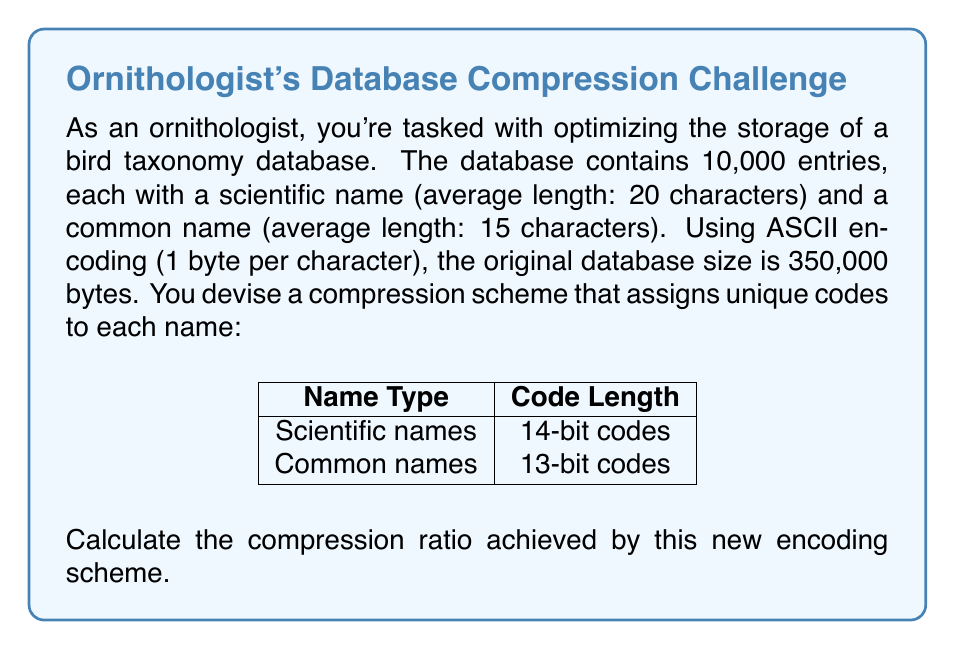Solve this math problem. To calculate the compression ratio, we need to compare the size of the compressed data to the original data size. Let's proceed step-by-step:

1. Original data size:
   - Scientific names: 10,000 × 20 characters = 200,000 bytes
   - Common names: 10,000 × 15 characters = 150,000 bytes
   - Total: 200,000 + 150,000 = 350,000 bytes

2. Compressed data size:
   - Scientific names: 10,000 × 14 bits = 140,000 bits
   - Common names: 10,000 × 13 bits = 130,000 bits
   - Total: 140,000 + 130,000 = 270,000 bits

3. Convert compressed size to bytes:
   $$\text{Compressed size in bytes} = \frac{270,000 \text{ bits}}{8 \text{ bits/byte}} = 33,750 \text{ bytes}$$

4. Calculate compression ratio:
   $$\text{Compression ratio} = \frac{\text{Original size}}{\text{Compressed size}} = \frac{350,000 \text{ bytes}}{33,750 \text{ bytes}} \approx 10.37$$

5. Express as a percentage:
   $$\text{Compression percentage} = \left(1 - \frac{1}{\text{Compression ratio}}\right) \times 100\% \approx 90.36\%$$

The compression ratio is approximately 10.37:1, meaning the compressed data takes up about 9.64% of the original space, saving about 90.36% of storage.
Answer: 10.37:1 